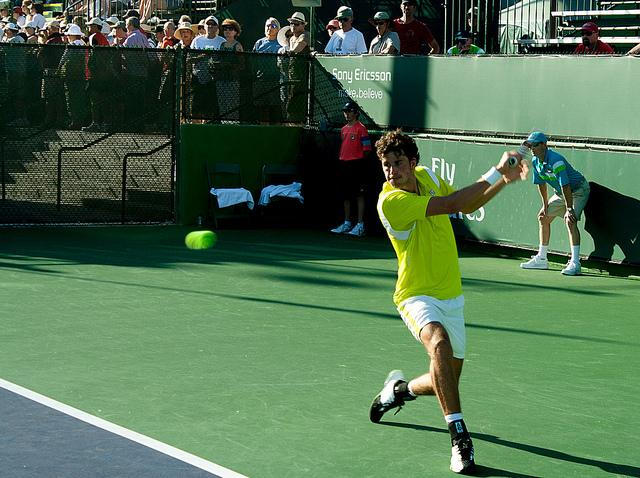Who are the people standing behind the gate? spectators 